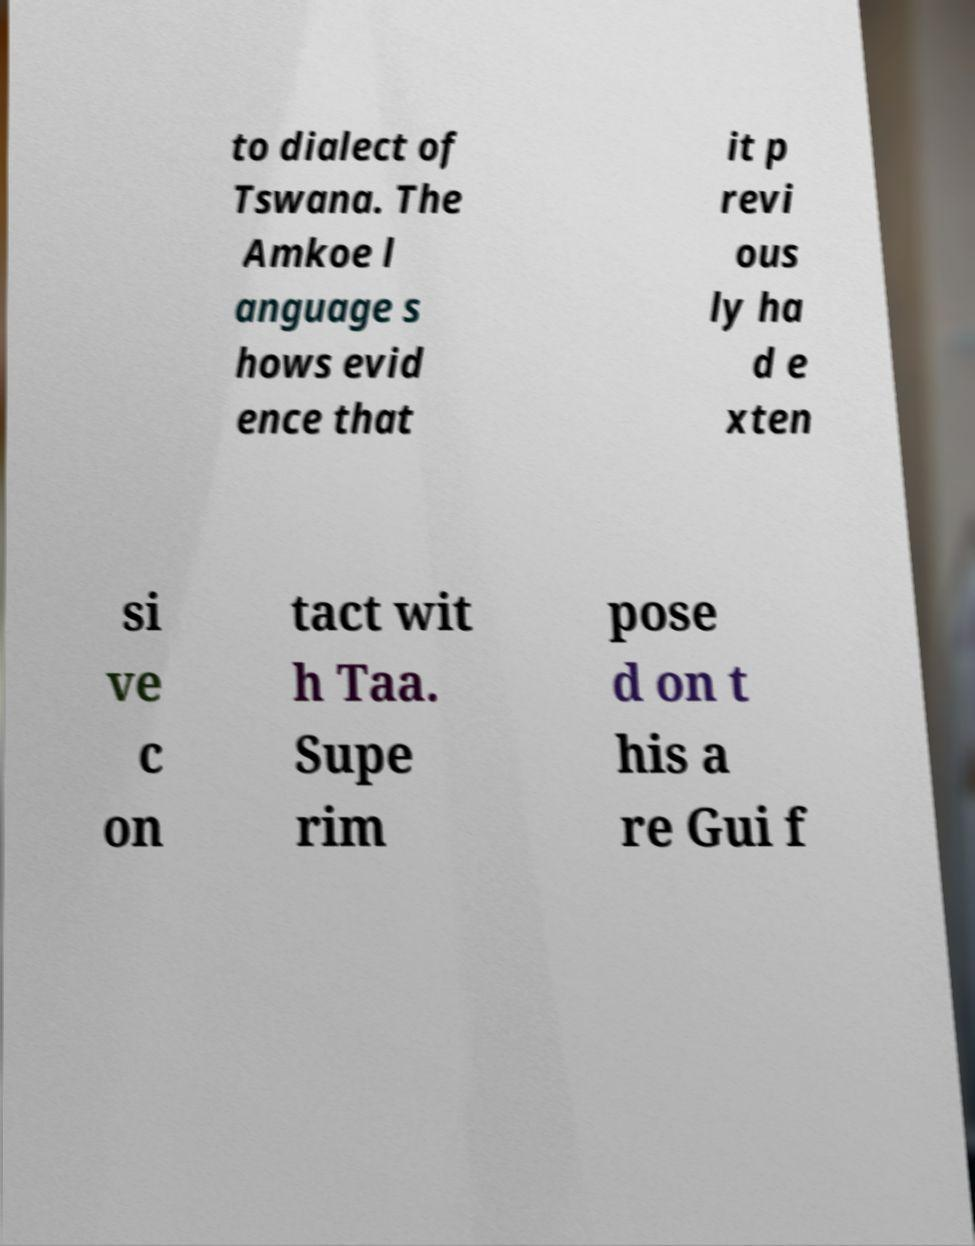Please identify and transcribe the text found in this image. to dialect of Tswana. The Amkoe l anguage s hows evid ence that it p revi ous ly ha d e xten si ve c on tact wit h Taa. Supe rim pose d on t his a re Gui f 